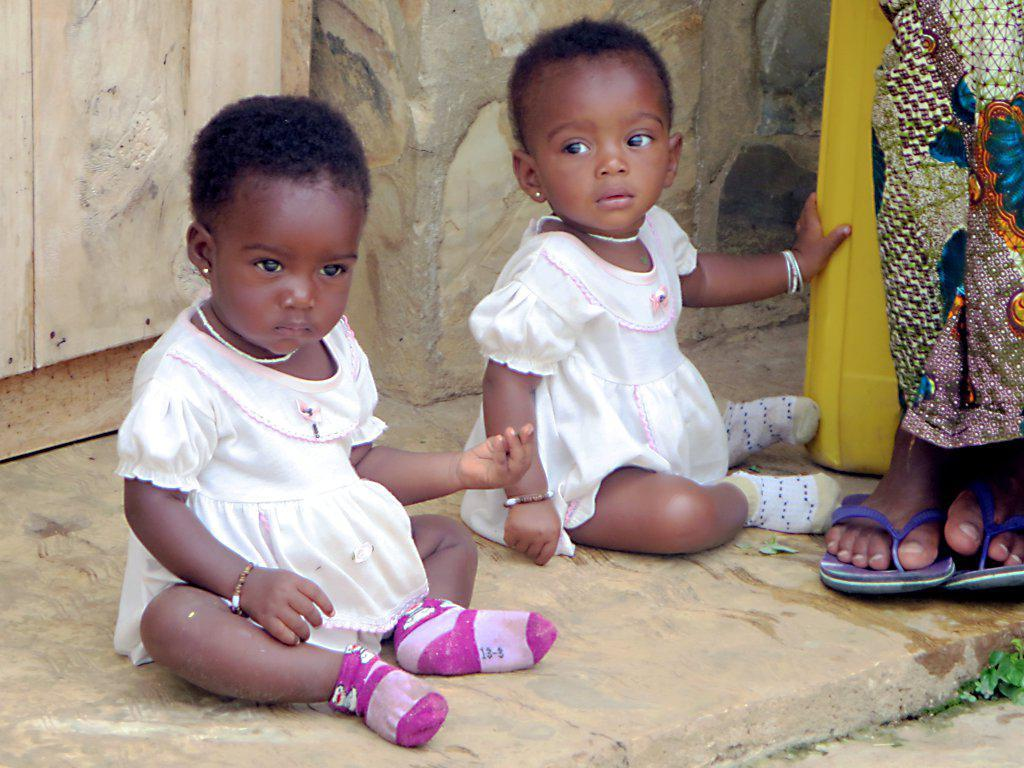How many kids are visible in the image? There are two kids sitting in the image. What can be seen in the background of the image? There is a wall and another person in the background of the image. Where is the plant located in the image? The plant is at the right bottom of the image. What type of plantation can be seen in the image? There is no plantation present in the image. What material is the sheet used by the kids in the image? There is no sheet visible in the image. 